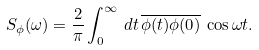Convert formula to latex. <formula><loc_0><loc_0><loc_500><loc_500>S _ { \phi } ( \omega ) = \frac { 2 } { \pi } \int _ { 0 } ^ { \infty } \, d t \, \overline { \phi ( t ) \phi ( 0 ) } \, \cos \omega t .</formula> 